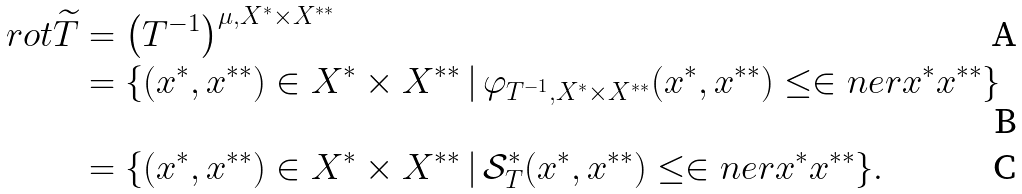Convert formula to latex. <formula><loc_0><loc_0><loc_500><loc_500>\ r o t \widetilde { T } & = \left ( T ^ { - 1 } \right ) ^ { \mu , X ^ { * } \times X ^ { * * } } \\ & = \{ ( x ^ { * } , x ^ { * * } ) \in X ^ { * } \times X ^ { * * } \, | \, \varphi _ { T ^ { - 1 } , X ^ { * } \times X ^ { * * } } ( x ^ { * } , x ^ { * * } ) \leq \in n e r { x ^ { * } } { x ^ { * * } } \} \\ & = \{ ( x ^ { * } , x ^ { * * } ) \in X ^ { * } \times X ^ { * * } \, | \, \mathcal { S } _ { T } ^ { * } ( x ^ { * } , x ^ { * * } ) \leq \in n e r { x ^ { * } } { x ^ { * * } } \} .</formula> 